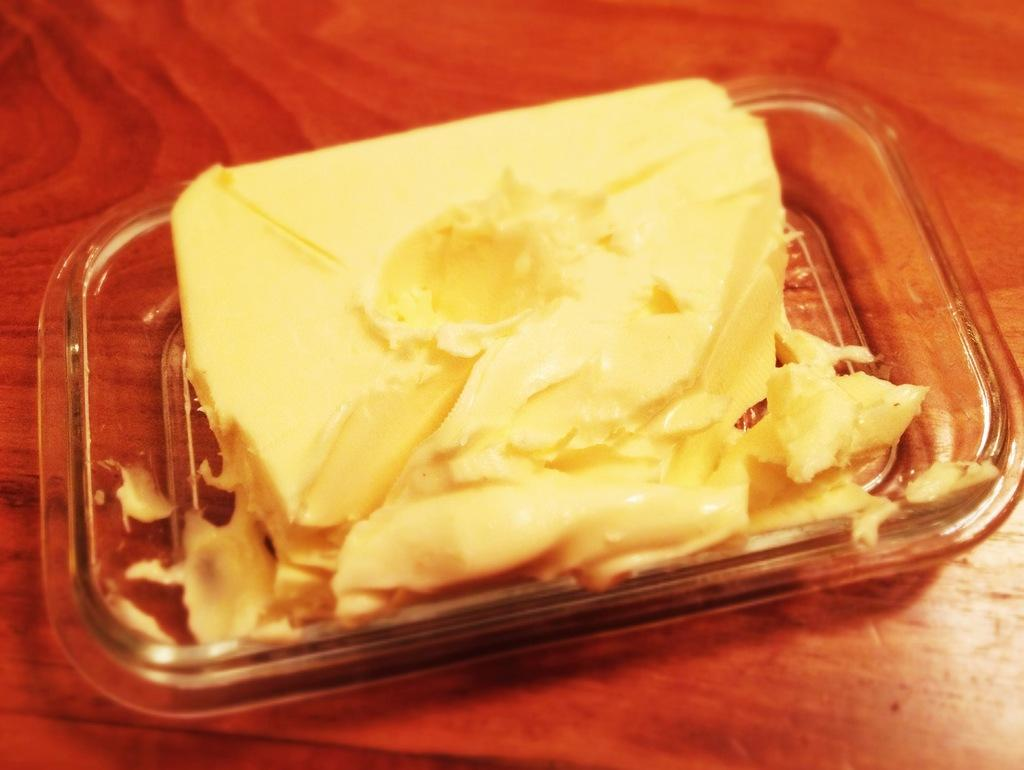What is the main subject of the image? The main subject of the image is a butter. How is the butter contained in the image? The butter is in a glass tray. What color is the surface on which the butter is placed? The butter is on a brown color surface. How many clams are present on the brown surface in the image? There are no clams present on the brown surface in the image; it only features a butter in a glass tray. 